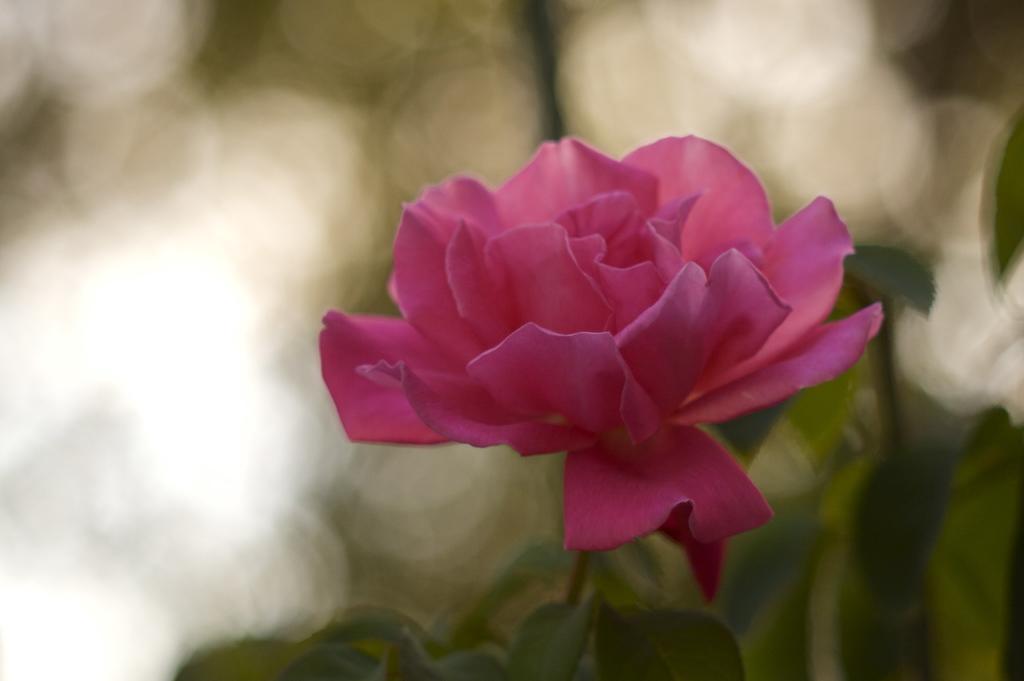How would you summarize this image in a sentence or two? Here in this picture we can see a flower present over a place. 